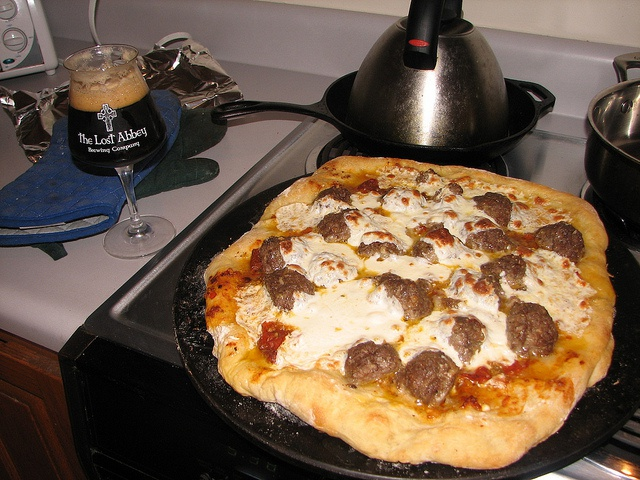Describe the objects in this image and their specific colors. I can see oven in gray, black, tan, and brown tones, pizza in gray, tan, brown, and beige tones, wine glass in gray, black, and tan tones, and microwave in gray tones in this image. 